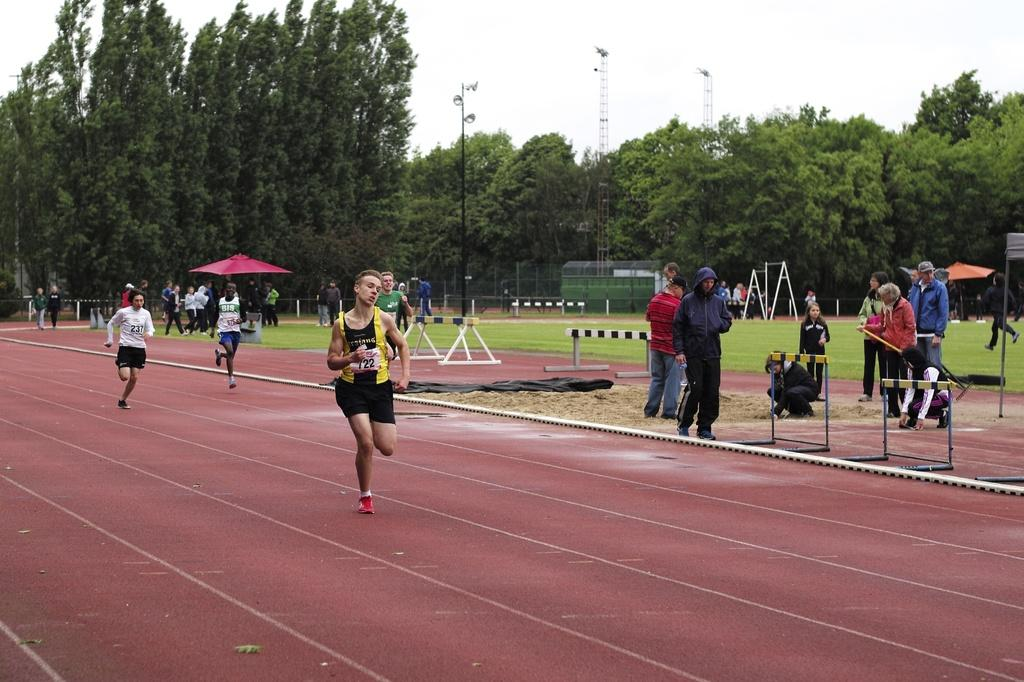How many people are in the image? There are people in the image, but the exact number is not specified. What are some of the people doing in the image? Some people are running, and some are standing. What is the main feature in the middle of the image? There is a garden in the middle of the image. What can be found in the garden? There are many trees in the garden. What is visible in the background of the image? The background of the image is the sky. What type of shoes are the people wearing while playing basketball in the image? There is no mention of basketball or shoes in the image; the facts only mention that some people are running and standing. 